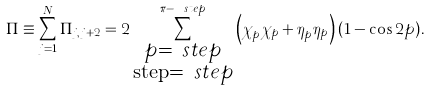Convert formula to latex. <formula><loc_0><loc_0><loc_500><loc_500>\Pi \equiv \sum _ { j = 1 } ^ { N } \Pi _ { j , j + 2 } = 2 \sum _ { \substack { p = \ s t e p \\ \text {step} = \ s t e p } } ^ { \pi - \ s t e p } \left ( \chi _ { p } ^ { \dagger } \chi _ { p } + \eta _ { p } ^ { \dagger } \eta _ { p } \right ) ( 1 - \cos 2 p ) .</formula> 